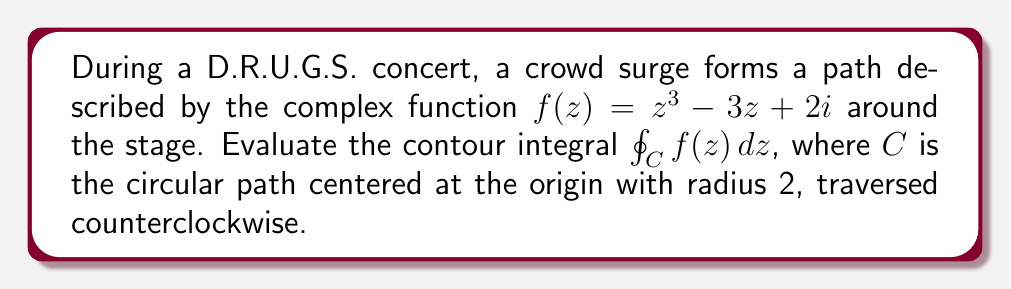Provide a solution to this math problem. To evaluate this contour integral, we'll use Cauchy's Integral Formula. First, let's analyze the function $f(z) = z^3 - 3z + 2i$.

1) We need to find the singularities of $f(z)$ inside the contour $C$. The function is entire (analytic everywhere), so there are no singularities.

2) Since $f(z)$ is analytic inside and on $C$, we can use the Cauchy-Goursat theorem, which states that for an analytic function inside and on a simple closed contour, the contour integral is zero.

3) Therefore, 

   $$\oint_C f(z) dz = 0$$

This result indicates that the net movement of the crowd surge around the stage cancels out, returning to its initial position after completing the circular path.

To verify this result, we could also use the parameterization of the circle:
$z = 2e^{i\theta}$, $0 \leq \theta \leq 2\pi$
$dz = 2ie^{i\theta}d\theta$

Then:

$$\oint_C f(z) dz = \int_0^{2\pi} f(2e^{i\theta}) \cdot 2ie^{i\theta}d\theta$$

$$= \int_0^{2\pi} ((2e^{i\theta})^3 - 3(2e^{i\theta}) + 2i) \cdot 2ie^{i\theta}d\theta$$

$$= \int_0^{2\pi} (8e^{3i\theta} - 6e^{i\theta} + 2i) \cdot 2ie^{i\theta}d\theta$$

$$= \int_0^{2\pi} (16ie^{4i\theta} - 12ie^{2i\theta} - 4e^{i\theta})d\theta$$

The integrals of $e^{4i\theta}$, $e^{2i\theta}$, and $e^{i\theta}$ over a full period are all zero, confirming our earlier conclusion.
Answer: $$\oint_C f(z) dz = 0$$ 